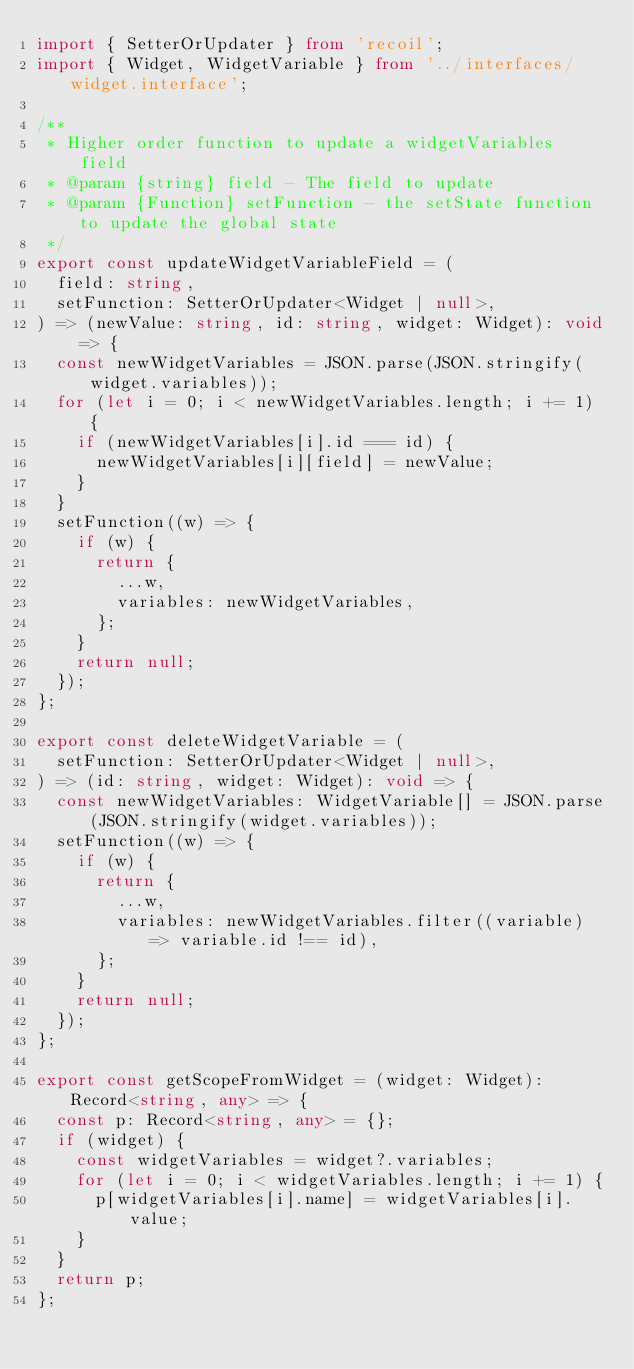<code> <loc_0><loc_0><loc_500><loc_500><_TypeScript_>import { SetterOrUpdater } from 'recoil';
import { Widget, WidgetVariable } from '../interfaces/widget.interface';

/**
 * Higher order function to update a widgetVariables field
 * @param {string} field - The field to update
 * @param {Function} setFunction - the setState function to update the global state
 */
export const updateWidgetVariableField = (
  field: string,
  setFunction: SetterOrUpdater<Widget | null>,
) => (newValue: string, id: string, widget: Widget): void => {
  const newWidgetVariables = JSON.parse(JSON.stringify(widget.variables));
  for (let i = 0; i < newWidgetVariables.length; i += 1) {
    if (newWidgetVariables[i].id === id) {
      newWidgetVariables[i][field] = newValue;
    }
  }
  setFunction((w) => {
    if (w) {
      return {
        ...w,
        variables: newWidgetVariables,
      };
    }
    return null;
  });
};

export const deleteWidgetVariable = (
  setFunction: SetterOrUpdater<Widget | null>,
) => (id: string, widget: Widget): void => {
  const newWidgetVariables: WidgetVariable[] = JSON.parse(JSON.stringify(widget.variables));
  setFunction((w) => {
    if (w) {
      return {
        ...w,
        variables: newWidgetVariables.filter((variable) => variable.id !== id),
      };
    }
    return null;
  });
};

export const getScopeFromWidget = (widget: Widget): Record<string, any> => {
  const p: Record<string, any> = {};
  if (widget) {
    const widgetVariables = widget?.variables;
    for (let i = 0; i < widgetVariables.length; i += 1) {
      p[widgetVariables[i].name] = widgetVariables[i].value;
    }
  }
  return p;
};
</code> 